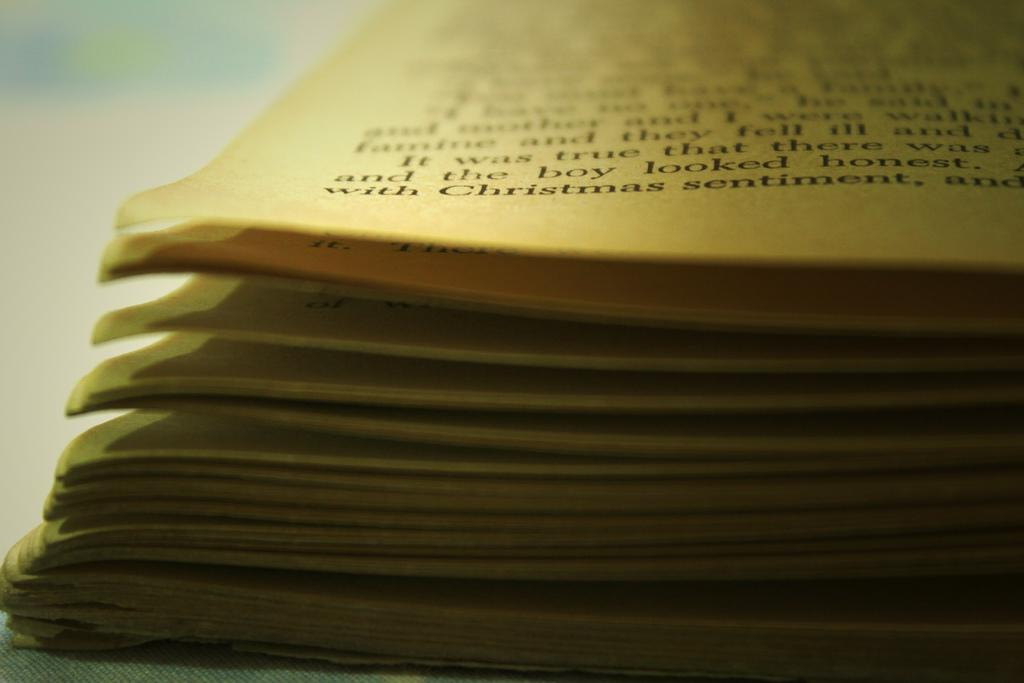<image>
Offer a succinct explanation of the picture presented. The phrase "with Christmas sentiment" is seen on the page of a book. 